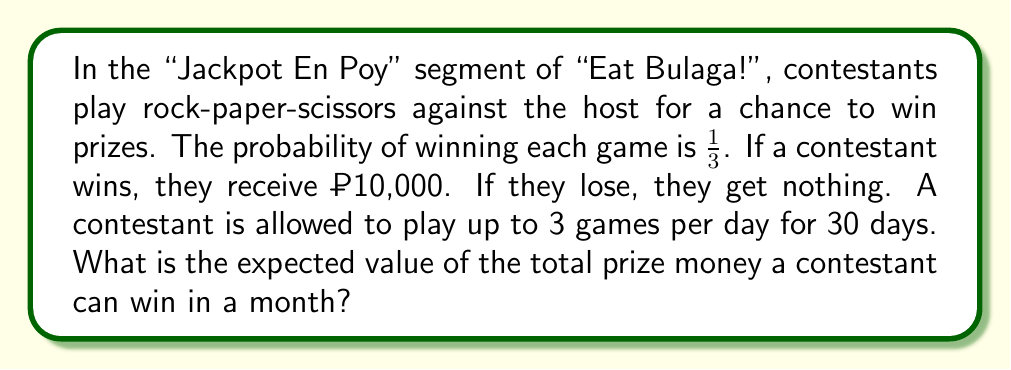Help me with this question. Let's approach this step-by-step:

1) First, we need to calculate the expected value for a single game:
   $$E(\text{single game}) = \frac{1}{3} \cdot ₱10,000 + \frac{2}{3} \cdot ₱0 = ₱3,333.33$$

2) A contestant can play up to 3 games per day. The expected value for one day is:
   $$E(\text{one day}) = 3 \cdot ₱3,333.33 = ₱10,000$$

3) The contest runs for 30 days. So, the expected value for the entire month is:
   $$E(\text{month}) = 30 \cdot ₱10,000 = ₱300,000$$

Therefore, the expected value of the total prize money a contestant can win in a month is ₱300,000.
Answer: ₱300,000 